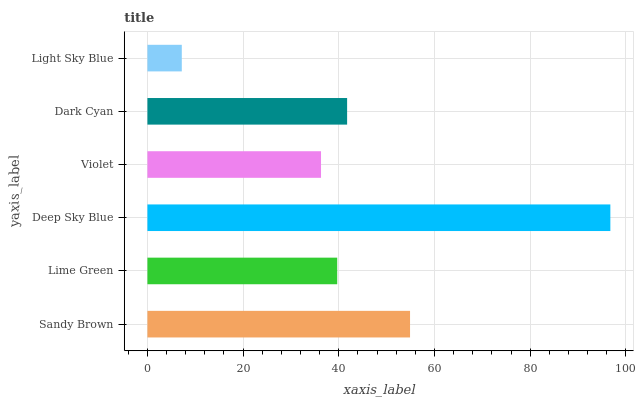Is Light Sky Blue the minimum?
Answer yes or no. Yes. Is Deep Sky Blue the maximum?
Answer yes or no. Yes. Is Lime Green the minimum?
Answer yes or no. No. Is Lime Green the maximum?
Answer yes or no. No. Is Sandy Brown greater than Lime Green?
Answer yes or no. Yes. Is Lime Green less than Sandy Brown?
Answer yes or no. Yes. Is Lime Green greater than Sandy Brown?
Answer yes or no. No. Is Sandy Brown less than Lime Green?
Answer yes or no. No. Is Dark Cyan the high median?
Answer yes or no. Yes. Is Lime Green the low median?
Answer yes or no. Yes. Is Violet the high median?
Answer yes or no. No. Is Deep Sky Blue the low median?
Answer yes or no. No. 